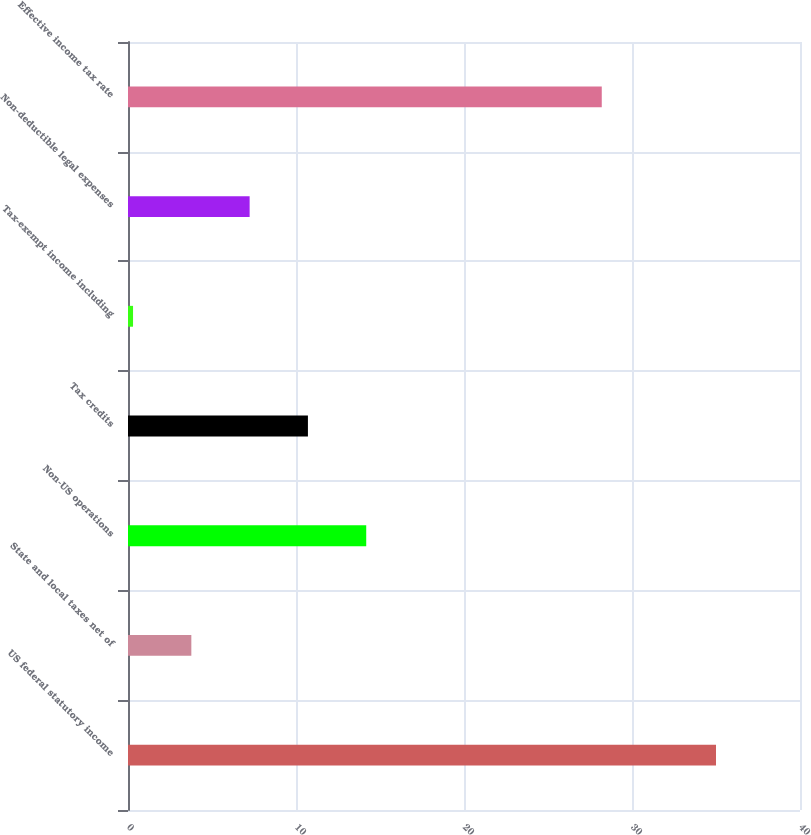Convert chart. <chart><loc_0><loc_0><loc_500><loc_500><bar_chart><fcel>US federal statutory income<fcel>State and local taxes net of<fcel>Non-US operations<fcel>Tax credits<fcel>Tax-exempt income including<fcel>Non-deductible legal expenses<fcel>Effective income tax rate<nl><fcel>35<fcel>3.77<fcel>14.18<fcel>10.71<fcel>0.3<fcel>7.24<fcel>28.2<nl></chart> 